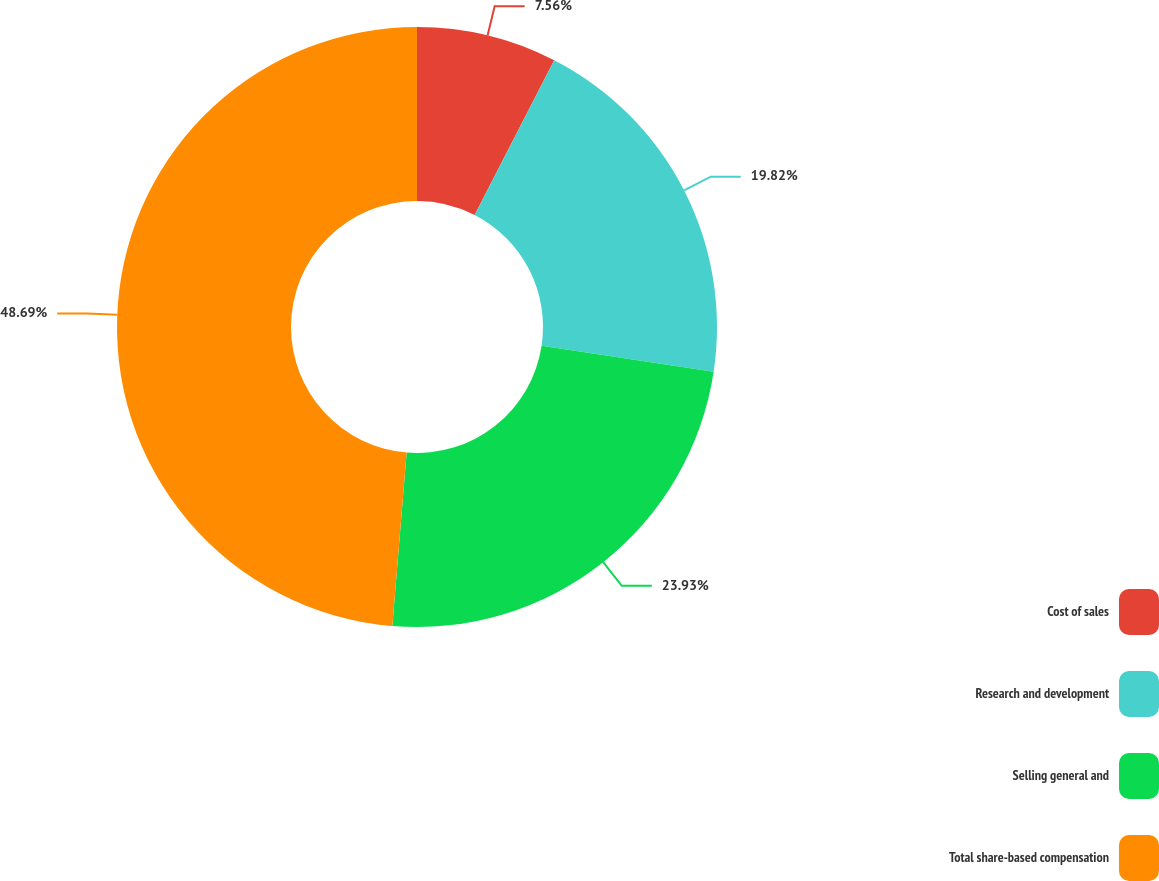<chart> <loc_0><loc_0><loc_500><loc_500><pie_chart><fcel>Cost of sales<fcel>Research and development<fcel>Selling general and<fcel>Total share-based compensation<nl><fcel>7.56%<fcel>19.82%<fcel>23.93%<fcel>48.69%<nl></chart> 